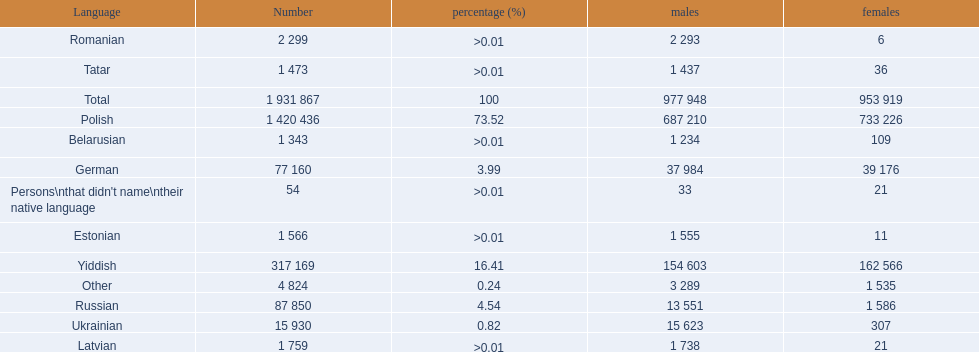What languages are spoken in the warsaw governorate? Polish, Yiddish, Russian, German, Ukrainian, Romanian, Latvian, Estonian, Tatar, Belarusian. Which are the top five languages? Polish, Yiddish, Russian, German, Ukrainian. Of those which is the 2nd most frequently spoken? Yiddish. 